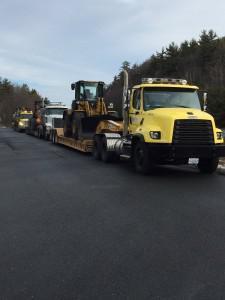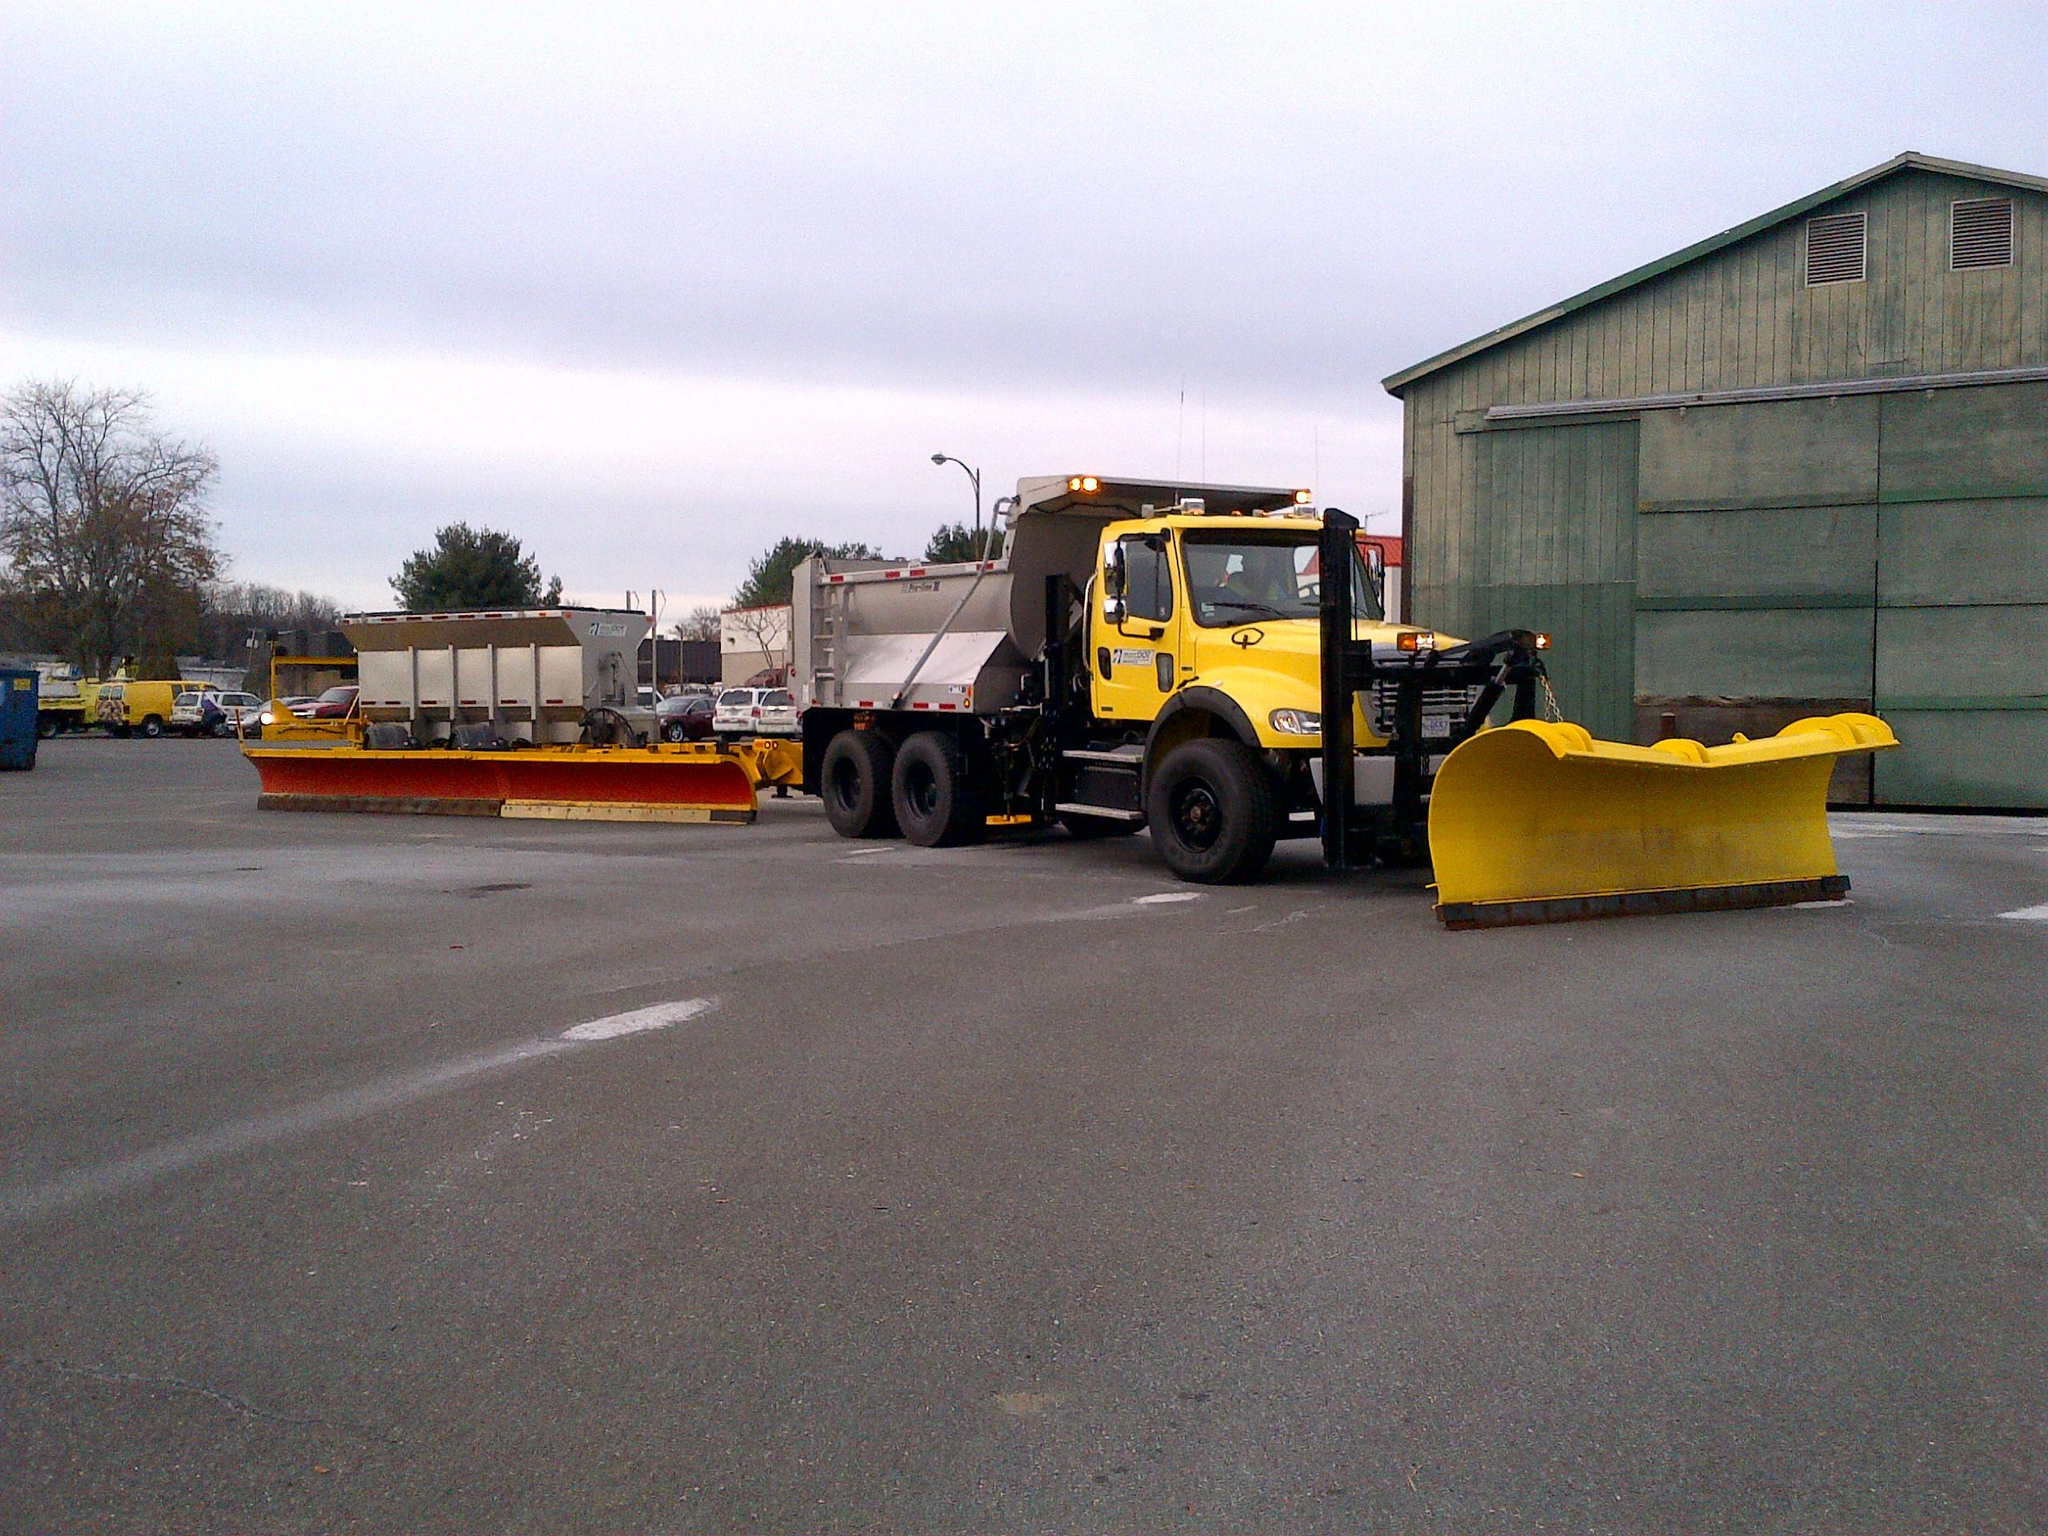The first image is the image on the left, the second image is the image on the right. Considering the images on both sides, is "An image shows a yellow-cabbed truck in front of a gray building, towing a trailer with a plow on the side." valid? Answer yes or no. Yes. The first image is the image on the left, the second image is the image on the right. Examine the images to the left and right. Is the description "The truck on the right has a plow, the truck on the left does not." accurate? Answer yes or no. Yes. 